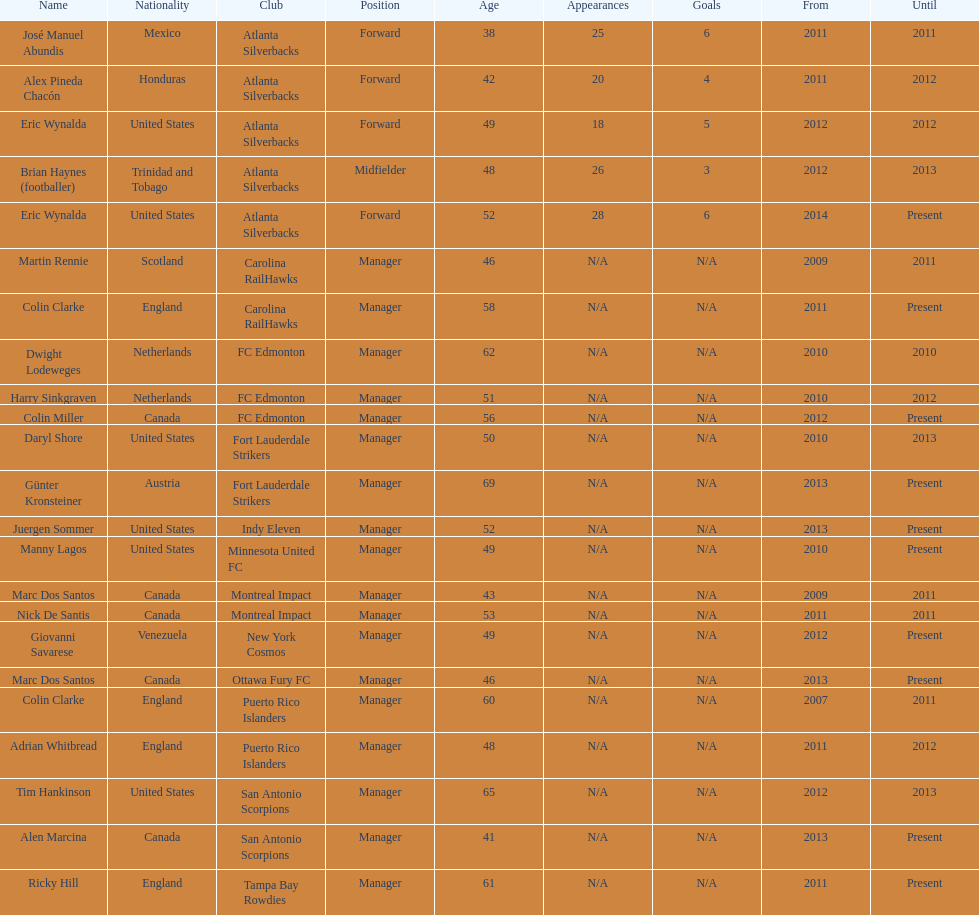Marc dos santos started as coach the same year as what other coach? Martin Rennie. 